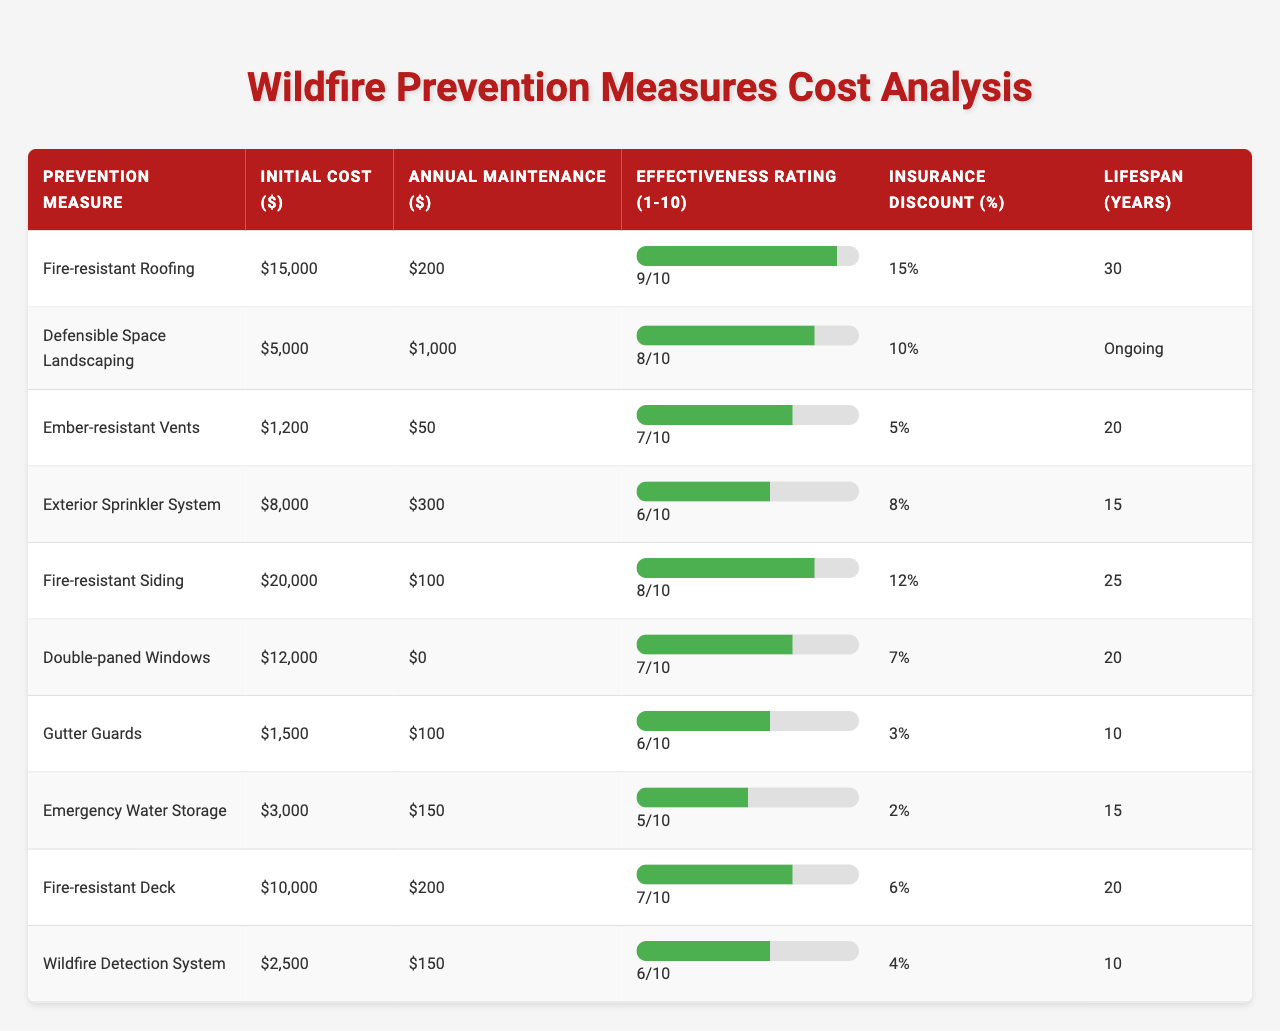What is the initial cost of Fire-resistant Roofing? The initial cost of Fire-resistant Roofing is specified in the table under the "Initial Cost ($)" column. It shows $15,000.
Answer: $15,000 What is the annual maintenance cost of Ember-resistant Vents? The annual maintenance cost of Ember-resistant Vents is listed in the table under the "Annual Maintenance ($)" column. It is $50.
Answer: $50 Is the effectiveness rating of Fire-resistant Siding higher than that of Double-paned Windows? The effectiveness rating for Fire-resistant Siding is 8, while for Double-paned Windows it is 7. Since 8 is greater than 7, the statement is true.
Answer: Yes What prevention measure has the longest lifespan? The lifespan for each prevention measure is compared in the "Lifespan (Years)" column. Fire-resistant Roofing has the longest lifespan of 30 years.
Answer: Fire-resistant Roofing What is the total initial cost of Fire-resistant Roofing and Fire-resistant Siding? The initial costs of these two measures are $15,000 for Fire-resistant Roofing and $20,000 for Fire-resistant Siding. Adding them gives $15,000 + $20,000 = $35,000.
Answer: $35,000 Which prevention measure offers the highest insurance discount? The insurance discounts in the table show Fire-resistant Roofing with a 15% discount, which is the highest percentage among all measures.
Answer: Fire-resistant Roofing What is the effectiveness rating of the prevention measures that cost less than $5,000? The measures that cost less than $5,000 are Ember-resistant Vents at 7, Gutter Guards at 6, and Wildfire Detection System at 6. The ratings are compared and listed together.
Answer: 7, 6, 6 If we combine the annual maintenance costs for all measures, what is the total? The annual maintenance costs from the table are summed: $200 (Roofing) + $1,000 (Landscaping) + $50 (Vents) + $300 (Sprinkler) + $100 (Siding) + $0 (Windows) + $100 (Guards) + $150 (Water) + $200 (Deck) + $150 (Detection) = $2,250.
Answer: $2,250 Are there any measures with an effectiveness rating below 6? By checking the "Effectiveness Rating (1-10)" column, the measures with ratings below 6 are the Emergency Water Storage and Gutter Guards, both rated at 5 and 6 respectively. Thus, the statement is true as Gutter Guards is also near the threshold.
Answer: Yes Which prevention measure combines the lowest initial cost with a high effectiveness rating above 8? Defensible Space Landscaping has an initial cost of $5,000 and an effectiveness rating of 8. All other options with higher ratings have higher costs. Therefore, it's identified as the least expensive with the desired rating.
Answer: Defensible Space Landscaping 